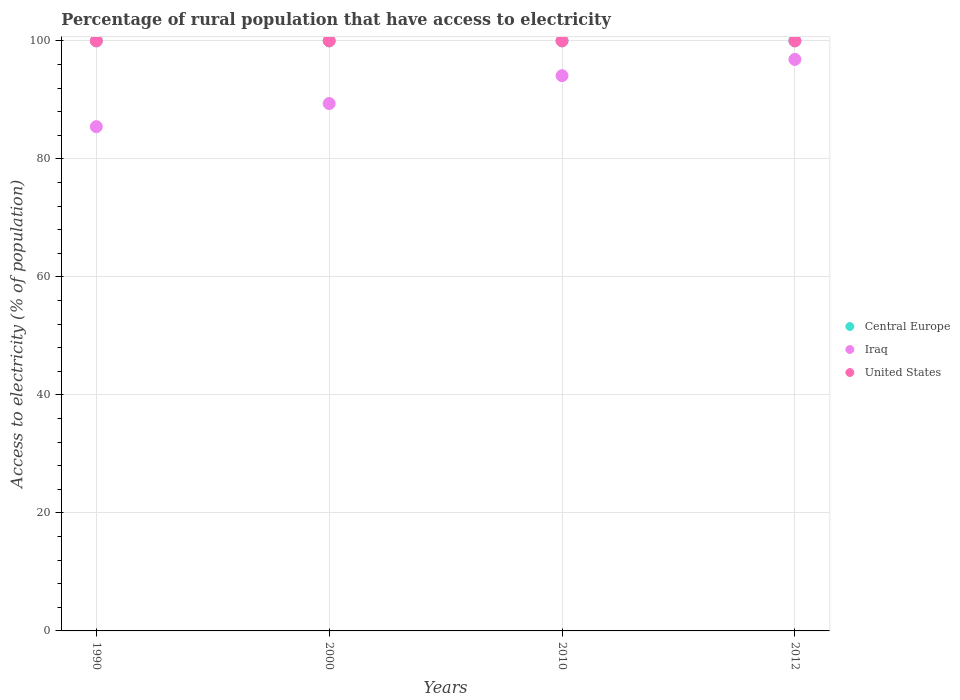How many different coloured dotlines are there?
Give a very brief answer. 3. Is the number of dotlines equal to the number of legend labels?
Provide a succinct answer. Yes. What is the percentage of rural population that have access to electricity in United States in 2000?
Offer a very short reply. 100. Across all years, what is the maximum percentage of rural population that have access to electricity in Central Europe?
Provide a short and direct response. 100. Across all years, what is the minimum percentage of rural population that have access to electricity in Central Europe?
Provide a short and direct response. 100. In which year was the percentage of rural population that have access to electricity in United States maximum?
Offer a terse response. 1990. What is the total percentage of rural population that have access to electricity in Iraq in the graph?
Provide a succinct answer. 365.8. What is the difference between the percentage of rural population that have access to electricity in Iraq in 1990 and the percentage of rural population that have access to electricity in Central Europe in 2010?
Keep it short and to the point. -14.54. Is the percentage of rural population that have access to electricity in Central Europe in 2000 less than that in 2012?
Offer a very short reply. No. What is the difference between the highest and the second highest percentage of rural population that have access to electricity in Iraq?
Provide a short and direct response. 2.75. In how many years, is the percentage of rural population that have access to electricity in Iraq greater than the average percentage of rural population that have access to electricity in Iraq taken over all years?
Your response must be concise. 2. Does the percentage of rural population that have access to electricity in Central Europe monotonically increase over the years?
Give a very brief answer. No. Is the percentage of rural population that have access to electricity in Central Europe strictly greater than the percentage of rural population that have access to electricity in Iraq over the years?
Ensure brevity in your answer.  Yes. Is the percentage of rural population that have access to electricity in United States strictly less than the percentage of rural population that have access to electricity in Central Europe over the years?
Keep it short and to the point. No. How many dotlines are there?
Give a very brief answer. 3. How many years are there in the graph?
Make the answer very short. 4. What is the difference between two consecutive major ticks on the Y-axis?
Provide a short and direct response. 20. Does the graph contain grids?
Give a very brief answer. Yes. Where does the legend appear in the graph?
Offer a terse response. Center right. How many legend labels are there?
Provide a short and direct response. 3. How are the legend labels stacked?
Ensure brevity in your answer.  Vertical. What is the title of the graph?
Your answer should be compact. Percentage of rural population that have access to electricity. Does "Nicaragua" appear as one of the legend labels in the graph?
Ensure brevity in your answer.  No. What is the label or title of the Y-axis?
Ensure brevity in your answer.  Access to electricity (% of population). What is the Access to electricity (% of population) of Central Europe in 1990?
Your response must be concise. 100. What is the Access to electricity (% of population) in Iraq in 1990?
Make the answer very short. 85.46. What is the Access to electricity (% of population) in United States in 1990?
Your response must be concise. 100. What is the Access to electricity (% of population) of Central Europe in 2000?
Offer a very short reply. 100. What is the Access to electricity (% of population) of Iraq in 2000?
Make the answer very short. 89.38. What is the Access to electricity (% of population) in Central Europe in 2010?
Ensure brevity in your answer.  100. What is the Access to electricity (% of population) in Iraq in 2010?
Keep it short and to the point. 94.1. What is the Access to electricity (% of population) of United States in 2010?
Your response must be concise. 100. What is the Access to electricity (% of population) of Central Europe in 2012?
Make the answer very short. 100. What is the Access to electricity (% of population) of Iraq in 2012?
Your answer should be compact. 96.85. What is the Access to electricity (% of population) of United States in 2012?
Provide a succinct answer. 100. Across all years, what is the maximum Access to electricity (% of population) of Iraq?
Keep it short and to the point. 96.85. Across all years, what is the minimum Access to electricity (% of population) of Iraq?
Provide a succinct answer. 85.46. What is the total Access to electricity (% of population) of Iraq in the graph?
Make the answer very short. 365.8. What is the difference between the Access to electricity (% of population) of Iraq in 1990 and that in 2000?
Provide a short and direct response. -3.92. What is the difference between the Access to electricity (% of population) of Central Europe in 1990 and that in 2010?
Provide a succinct answer. 0. What is the difference between the Access to electricity (% of population) in Iraq in 1990 and that in 2010?
Provide a short and direct response. -8.64. What is the difference between the Access to electricity (% of population) of Central Europe in 1990 and that in 2012?
Ensure brevity in your answer.  0. What is the difference between the Access to electricity (% of population) of Iraq in 1990 and that in 2012?
Offer a very short reply. -11.39. What is the difference between the Access to electricity (% of population) in United States in 1990 and that in 2012?
Provide a succinct answer. 0. What is the difference between the Access to electricity (% of population) of Iraq in 2000 and that in 2010?
Offer a terse response. -4.72. What is the difference between the Access to electricity (% of population) of United States in 2000 and that in 2010?
Provide a succinct answer. 0. What is the difference between the Access to electricity (% of population) in Central Europe in 2000 and that in 2012?
Offer a very short reply. 0. What is the difference between the Access to electricity (% of population) of Iraq in 2000 and that in 2012?
Your answer should be compact. -7.47. What is the difference between the Access to electricity (% of population) of United States in 2000 and that in 2012?
Ensure brevity in your answer.  0. What is the difference between the Access to electricity (% of population) in Central Europe in 2010 and that in 2012?
Your response must be concise. 0. What is the difference between the Access to electricity (% of population) of Iraq in 2010 and that in 2012?
Keep it short and to the point. -2.75. What is the difference between the Access to electricity (% of population) of Central Europe in 1990 and the Access to electricity (% of population) of Iraq in 2000?
Give a very brief answer. 10.62. What is the difference between the Access to electricity (% of population) of Central Europe in 1990 and the Access to electricity (% of population) of United States in 2000?
Your answer should be compact. 0. What is the difference between the Access to electricity (% of population) of Iraq in 1990 and the Access to electricity (% of population) of United States in 2000?
Your response must be concise. -14.54. What is the difference between the Access to electricity (% of population) of Central Europe in 1990 and the Access to electricity (% of population) of Iraq in 2010?
Your answer should be very brief. 5.9. What is the difference between the Access to electricity (% of population) of Central Europe in 1990 and the Access to electricity (% of population) of United States in 2010?
Offer a very short reply. 0. What is the difference between the Access to electricity (% of population) in Iraq in 1990 and the Access to electricity (% of population) in United States in 2010?
Your answer should be compact. -14.54. What is the difference between the Access to electricity (% of population) in Central Europe in 1990 and the Access to electricity (% of population) in Iraq in 2012?
Ensure brevity in your answer.  3.15. What is the difference between the Access to electricity (% of population) in Central Europe in 1990 and the Access to electricity (% of population) in United States in 2012?
Offer a very short reply. 0. What is the difference between the Access to electricity (% of population) in Iraq in 1990 and the Access to electricity (% of population) in United States in 2012?
Provide a succinct answer. -14.54. What is the difference between the Access to electricity (% of population) of Central Europe in 2000 and the Access to electricity (% of population) of United States in 2010?
Your response must be concise. 0. What is the difference between the Access to electricity (% of population) of Iraq in 2000 and the Access to electricity (% of population) of United States in 2010?
Give a very brief answer. -10.62. What is the difference between the Access to electricity (% of population) of Central Europe in 2000 and the Access to electricity (% of population) of Iraq in 2012?
Keep it short and to the point. 3.15. What is the difference between the Access to electricity (% of population) in Iraq in 2000 and the Access to electricity (% of population) in United States in 2012?
Provide a succinct answer. -10.62. What is the difference between the Access to electricity (% of population) of Central Europe in 2010 and the Access to electricity (% of population) of Iraq in 2012?
Make the answer very short. 3.15. What is the difference between the Access to electricity (% of population) in Central Europe in 2010 and the Access to electricity (% of population) in United States in 2012?
Offer a very short reply. 0. What is the average Access to electricity (% of population) in Central Europe per year?
Make the answer very short. 100. What is the average Access to electricity (% of population) in Iraq per year?
Keep it short and to the point. 91.45. What is the average Access to electricity (% of population) of United States per year?
Give a very brief answer. 100. In the year 1990, what is the difference between the Access to electricity (% of population) of Central Europe and Access to electricity (% of population) of Iraq?
Offer a very short reply. 14.54. In the year 1990, what is the difference between the Access to electricity (% of population) in Iraq and Access to electricity (% of population) in United States?
Keep it short and to the point. -14.54. In the year 2000, what is the difference between the Access to electricity (% of population) in Central Europe and Access to electricity (% of population) in Iraq?
Your response must be concise. 10.62. In the year 2000, what is the difference between the Access to electricity (% of population) of Iraq and Access to electricity (% of population) of United States?
Make the answer very short. -10.62. In the year 2010, what is the difference between the Access to electricity (% of population) of Central Europe and Access to electricity (% of population) of Iraq?
Ensure brevity in your answer.  5.9. In the year 2010, what is the difference between the Access to electricity (% of population) in Central Europe and Access to electricity (% of population) in United States?
Provide a short and direct response. 0. In the year 2012, what is the difference between the Access to electricity (% of population) of Central Europe and Access to electricity (% of population) of Iraq?
Ensure brevity in your answer.  3.15. In the year 2012, what is the difference between the Access to electricity (% of population) of Central Europe and Access to electricity (% of population) of United States?
Your answer should be very brief. 0. In the year 2012, what is the difference between the Access to electricity (% of population) of Iraq and Access to electricity (% of population) of United States?
Ensure brevity in your answer.  -3.15. What is the ratio of the Access to electricity (% of population) in Iraq in 1990 to that in 2000?
Make the answer very short. 0.96. What is the ratio of the Access to electricity (% of population) in United States in 1990 to that in 2000?
Keep it short and to the point. 1. What is the ratio of the Access to electricity (% of population) in Iraq in 1990 to that in 2010?
Your response must be concise. 0.91. What is the ratio of the Access to electricity (% of population) in Iraq in 1990 to that in 2012?
Keep it short and to the point. 0.88. What is the ratio of the Access to electricity (% of population) of Iraq in 2000 to that in 2010?
Keep it short and to the point. 0.95. What is the ratio of the Access to electricity (% of population) in Central Europe in 2000 to that in 2012?
Give a very brief answer. 1. What is the ratio of the Access to electricity (% of population) in Iraq in 2000 to that in 2012?
Ensure brevity in your answer.  0.92. What is the ratio of the Access to electricity (% of population) in United States in 2000 to that in 2012?
Ensure brevity in your answer.  1. What is the ratio of the Access to electricity (% of population) of Central Europe in 2010 to that in 2012?
Make the answer very short. 1. What is the ratio of the Access to electricity (% of population) of Iraq in 2010 to that in 2012?
Your response must be concise. 0.97. What is the ratio of the Access to electricity (% of population) in United States in 2010 to that in 2012?
Offer a very short reply. 1. What is the difference between the highest and the second highest Access to electricity (% of population) of Central Europe?
Your answer should be compact. 0. What is the difference between the highest and the second highest Access to electricity (% of population) in Iraq?
Keep it short and to the point. 2.75. What is the difference between the highest and the second highest Access to electricity (% of population) in United States?
Offer a very short reply. 0. What is the difference between the highest and the lowest Access to electricity (% of population) of Central Europe?
Make the answer very short. 0. What is the difference between the highest and the lowest Access to electricity (% of population) in Iraq?
Give a very brief answer. 11.39. 